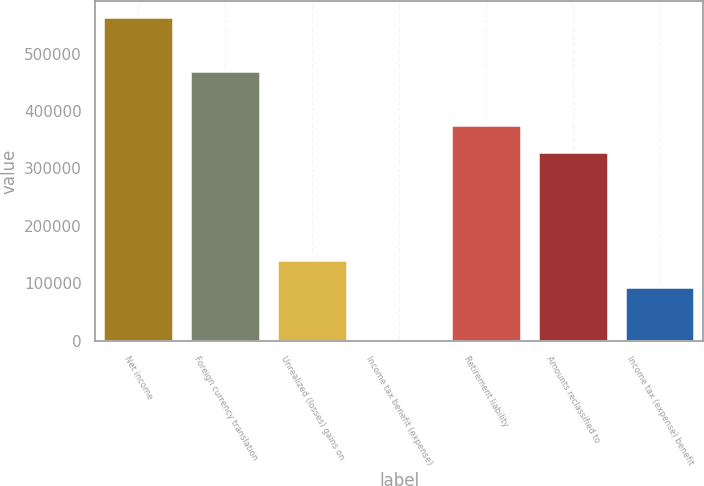Convert chart. <chart><loc_0><loc_0><loc_500><loc_500><bar_chart><fcel>Net income<fcel>Foreign currency translation<fcel>Unrealized (losses) gains on<fcel>Income tax benefit (expense)<fcel>Retirement liability<fcel>Amounts reclassified to<fcel>Income tax (expense) benefit<nl><fcel>562857<fcel>469053<fcel>140738<fcel>31<fcel>375249<fcel>328346<fcel>93835.4<nl></chart> 